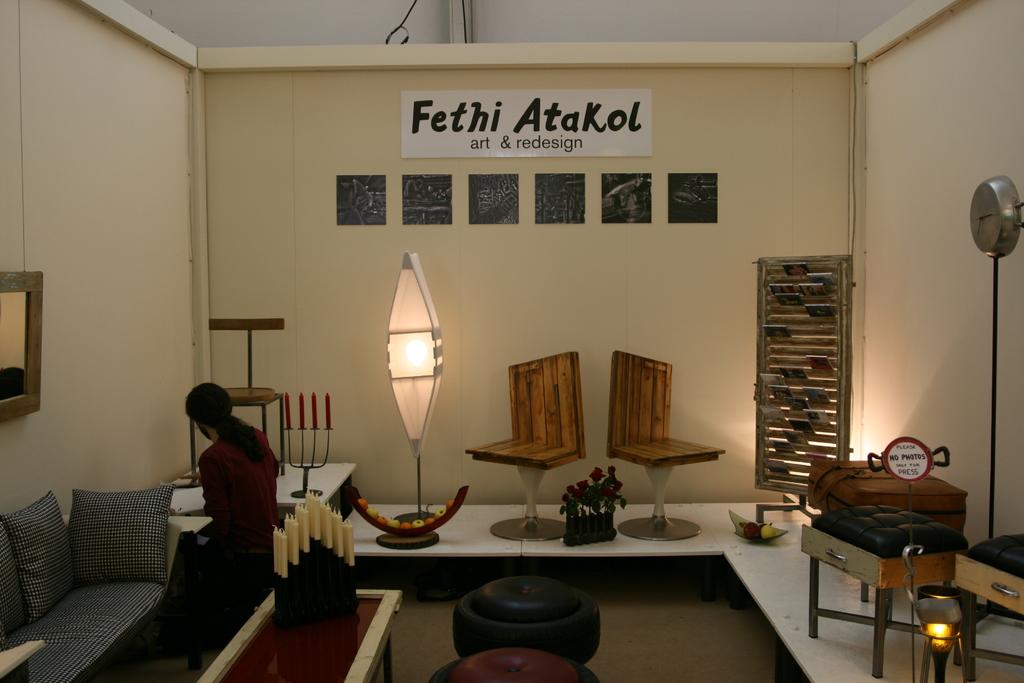What name is on the banner?
Your answer should be compact. Fethi atakol. What is the tagline below the name?
Give a very brief answer. Art & redesign. 